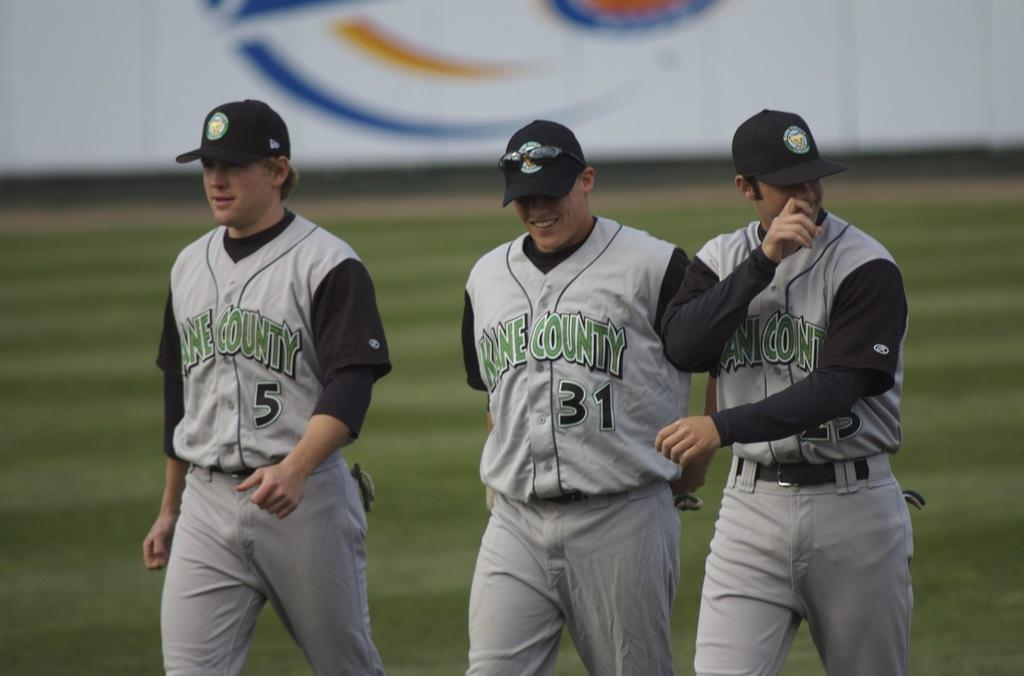<image>
Create a compact narrative representing the image presented. three baseball players that are from Kane County 